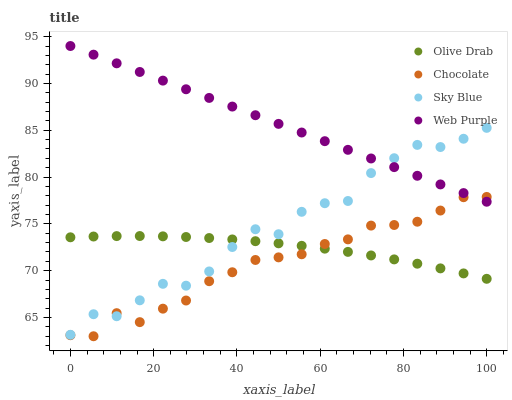Does Chocolate have the minimum area under the curve?
Answer yes or no. Yes. Does Web Purple have the maximum area under the curve?
Answer yes or no. Yes. Does Olive Drab have the minimum area under the curve?
Answer yes or no. No. Does Olive Drab have the maximum area under the curve?
Answer yes or no. No. Is Web Purple the smoothest?
Answer yes or no. Yes. Is Sky Blue the roughest?
Answer yes or no. Yes. Is Olive Drab the smoothest?
Answer yes or no. No. Is Olive Drab the roughest?
Answer yes or no. No. Does Chocolate have the lowest value?
Answer yes or no. Yes. Does Olive Drab have the lowest value?
Answer yes or no. No. Does Web Purple have the highest value?
Answer yes or no. Yes. Does Olive Drab have the highest value?
Answer yes or no. No. Is Olive Drab less than Web Purple?
Answer yes or no. Yes. Is Web Purple greater than Olive Drab?
Answer yes or no. Yes. Does Olive Drab intersect Sky Blue?
Answer yes or no. Yes. Is Olive Drab less than Sky Blue?
Answer yes or no. No. Is Olive Drab greater than Sky Blue?
Answer yes or no. No. Does Olive Drab intersect Web Purple?
Answer yes or no. No. 